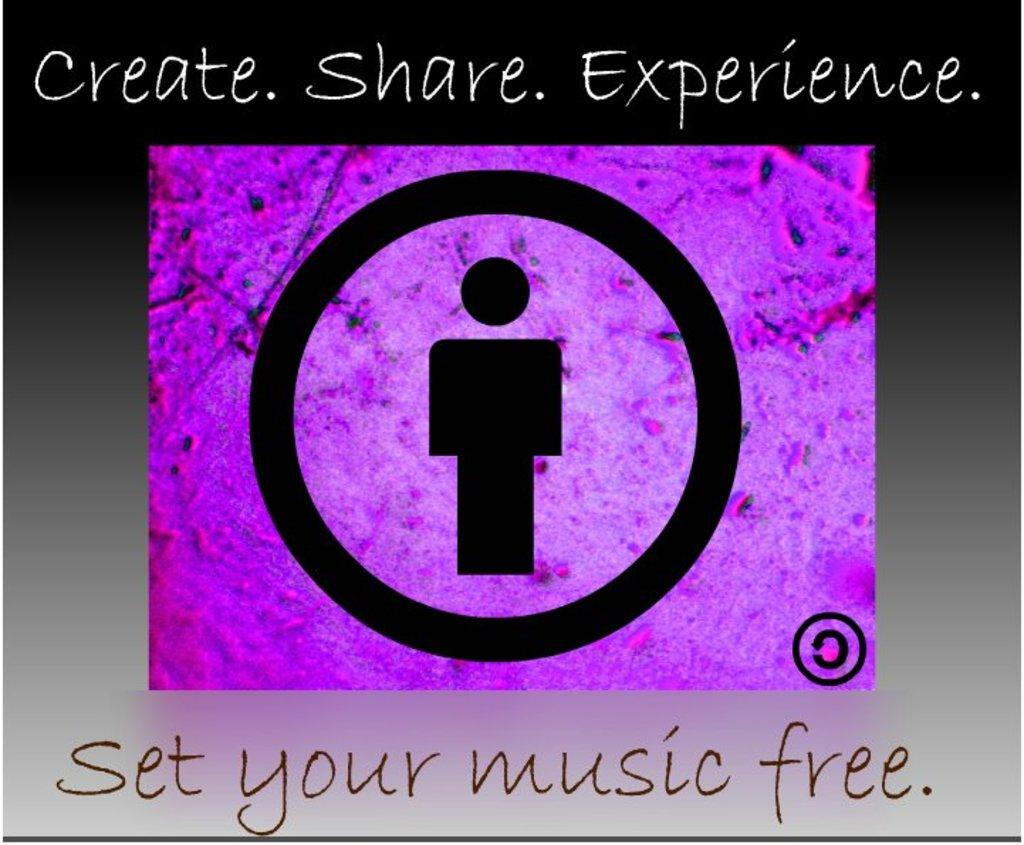<image>
Give a short and clear explanation of the subsequent image. Purple sign with a symbol on it and the words "Set your music free". 